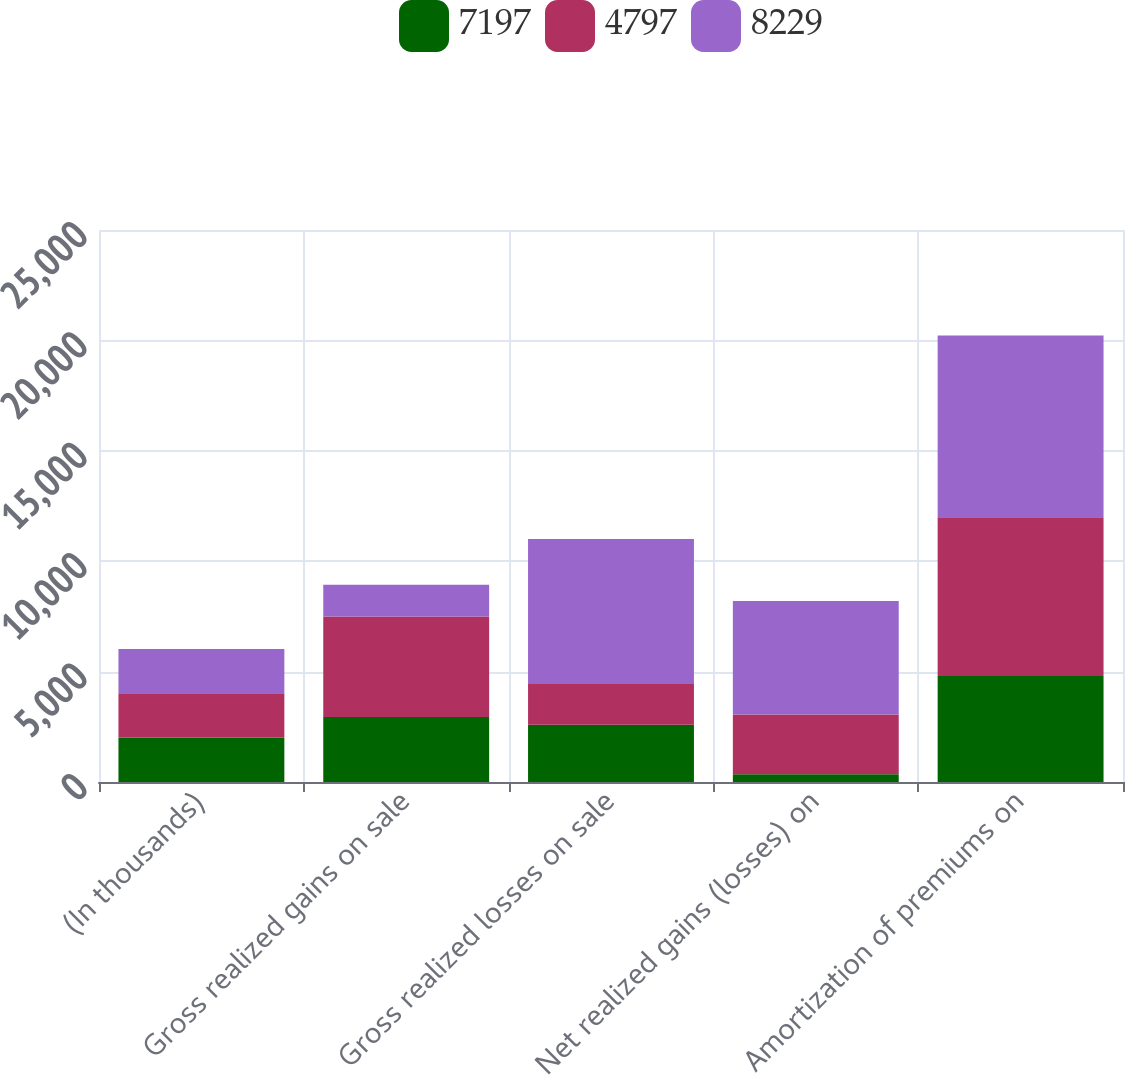Convert chart. <chart><loc_0><loc_0><loc_500><loc_500><stacked_bar_chart><ecel><fcel>(In thousands)<fcel>Gross realized gains on sale<fcel>Gross realized losses on sale<fcel>Net realized gains (losses) on<fcel>Amortization of premiums on<nl><fcel>7197<fcel>2010<fcel>2947<fcel>2596<fcel>351<fcel>4797<nl><fcel>4797<fcel>2009<fcel>4544<fcel>1838<fcel>2706<fcel>7197<nl><fcel>8229<fcel>2008<fcel>1437<fcel>6576<fcel>5139<fcel>8229<nl></chart> 